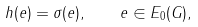Convert formula to latex. <formula><loc_0><loc_0><loc_500><loc_500>h ( e ) = \sigma ( e ) , \quad e \in E _ { 0 } ( G ) ,</formula> 